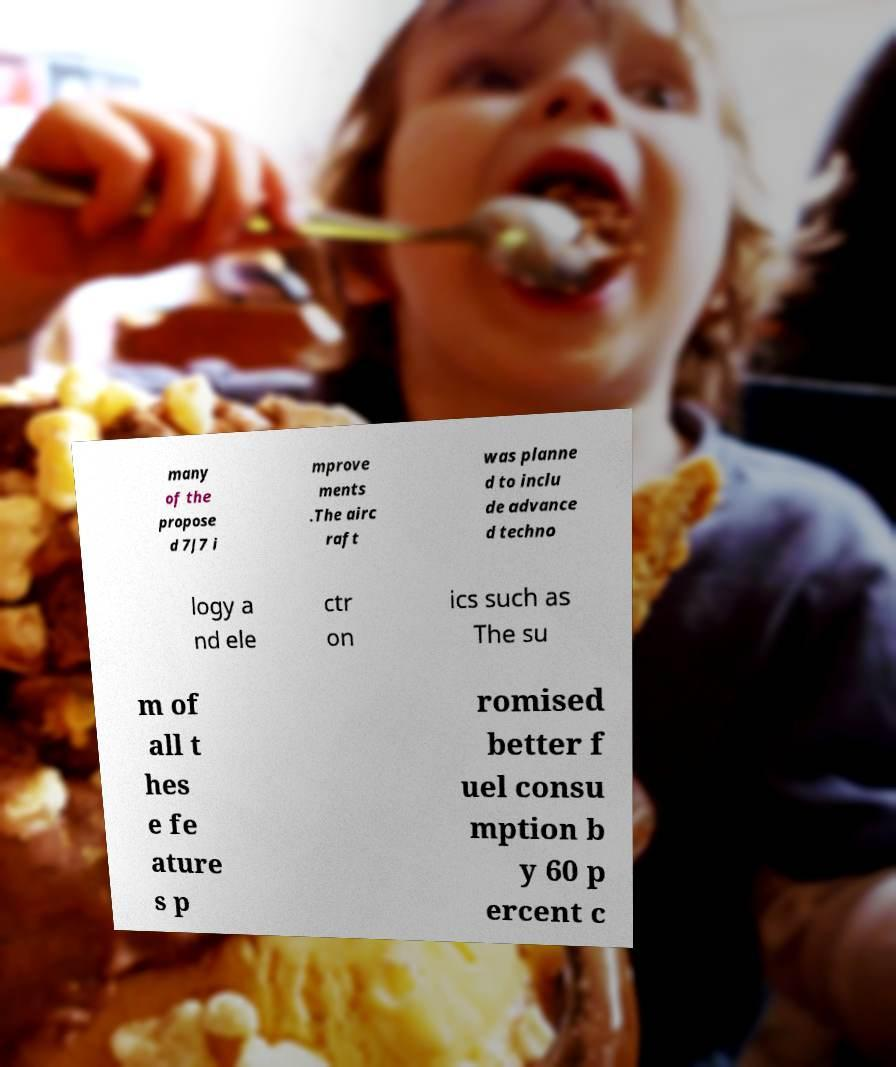For documentation purposes, I need the text within this image transcribed. Could you provide that? many of the propose d 7J7 i mprove ments .The airc raft was planne d to inclu de advance d techno logy a nd ele ctr on ics such as The su m of all t hes e fe ature s p romised better f uel consu mption b y 60 p ercent c 